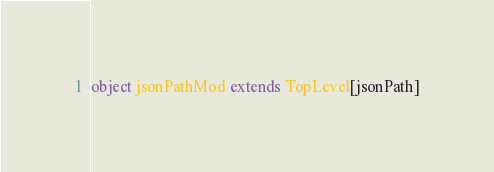Convert code to text. <code><loc_0><loc_0><loc_500><loc_500><_Scala_>object jsonPathMod extends TopLevel[jsonPath]

</code> 